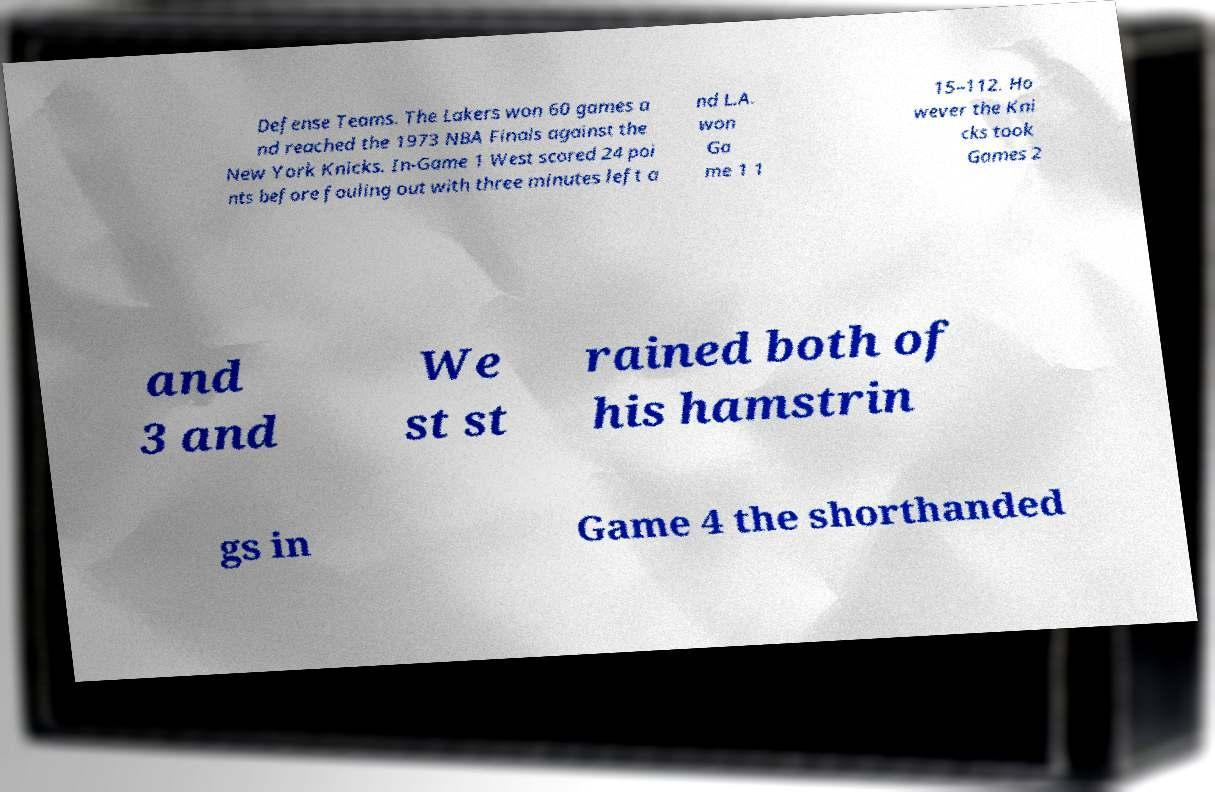There's text embedded in this image that I need extracted. Can you transcribe it verbatim? Defense Teams. The Lakers won 60 games a nd reached the 1973 NBA Finals against the New York Knicks. In-Game 1 West scored 24 poi nts before fouling out with three minutes left a nd L.A. won Ga me 1 1 15–112. Ho wever the Kni cks took Games 2 and 3 and We st st rained both of his hamstrin gs in Game 4 the shorthanded 